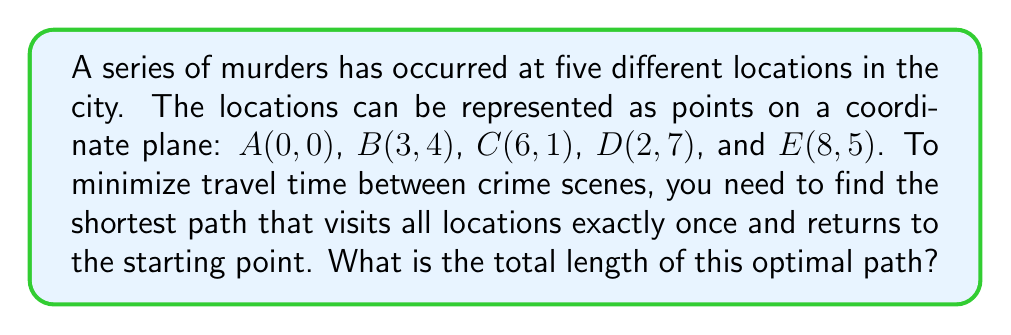What is the answer to this math problem? To solve this problem, we need to use the concept of the Traveling Salesman Problem (TSP) and calculate distances between points using the distance formula.

Step 1: Calculate distances between all pairs of points using the distance formula:
$d = \sqrt{(x_2-x_1)^2 + (y_2-y_1)^2}$

AB = $\sqrt{(3-0)^2 + (4-0)^2} = 5$
AC = $\sqrt{(6-0)^2 + (1-0)^2} = \sqrt{37}$
AD = $\sqrt{(2-0)^2 + (7-0)^2} = \sqrt{53}$
AE = $\sqrt{(8-0)^2 + (5-0)^2} = \sqrt{89}$
BC = $\sqrt{(6-3)^2 + (1-4)^2} = \sqrt{18}$
BD = $\sqrt{(2-3)^2 + (7-4)^2} = \sqrt{10}$
BE = $\sqrt{(8-3)^2 + (5-4)^2} = \sqrt{26}$
CD = $\sqrt{(2-6)^2 + (7-1)^2} = \sqrt{52}$
CE = $\sqrt{(8-6)^2 + (5-1)^2} = \sqrt{20}$
DE = $\sqrt{(8-2)^2 + (5-7)^2} = \sqrt{40}$

Step 2: Find the shortest path by trying all possible permutations (5! = 120 possibilities). The optimal path is:

A → B → D → E → C → A

Step 3: Calculate the total length of the optimal path:
$$ \text{Total Length} = AB + BD + DE + EC + CA $$
$$ = 5 + \sqrt{10} + \sqrt{40} + \sqrt{20} + \sqrt{37} $$
$$ = 5 + \sqrt{10} + 2\sqrt{10} + 2\sqrt{5} + \sqrt{37} $$
$$ = 5 + 3\sqrt{10} + 2\sqrt{5} + \sqrt{37} $$

Step 4: Simplify the expression (if needed) or leave it in this form for precise representation.
Answer: $5 + 3\sqrt{10} + 2\sqrt{5} + \sqrt{37}$ 